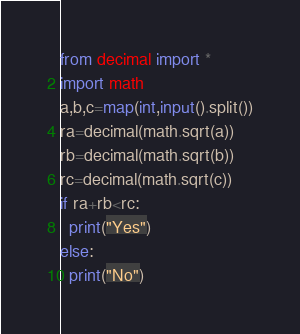Convert code to text. <code><loc_0><loc_0><loc_500><loc_500><_Python_>from decimal import *
import math
a,b,c=map(int,input().split())
ra=decimal(math.sqrt(a))
rb=decimal(math.sqrt(b))
rc=decimal(math.sqrt(c))
if ra+rb<rc:
  print("Yes")
else:
  print("No")</code> 